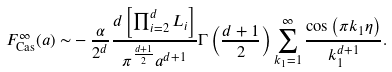<formula> <loc_0><loc_0><loc_500><loc_500>F ^ { \infty } _ { \text {Cas} } ( a ) \sim & - \frac { \alpha } { 2 ^ { d } } \frac { d \left [ \prod _ { i = 2 } ^ { d } L _ { i } \right ] } { \pi ^ { \frac { d + 1 } { 2 } } a ^ { d + 1 } } \Gamma \left ( \frac { d + 1 } { 2 } \right ) \sum _ { k _ { 1 } = 1 } ^ { \infty } \frac { \cos \left ( \pi k _ { 1 } \eta \right ) } { k _ { 1 } ^ { d + 1 } } .</formula> 